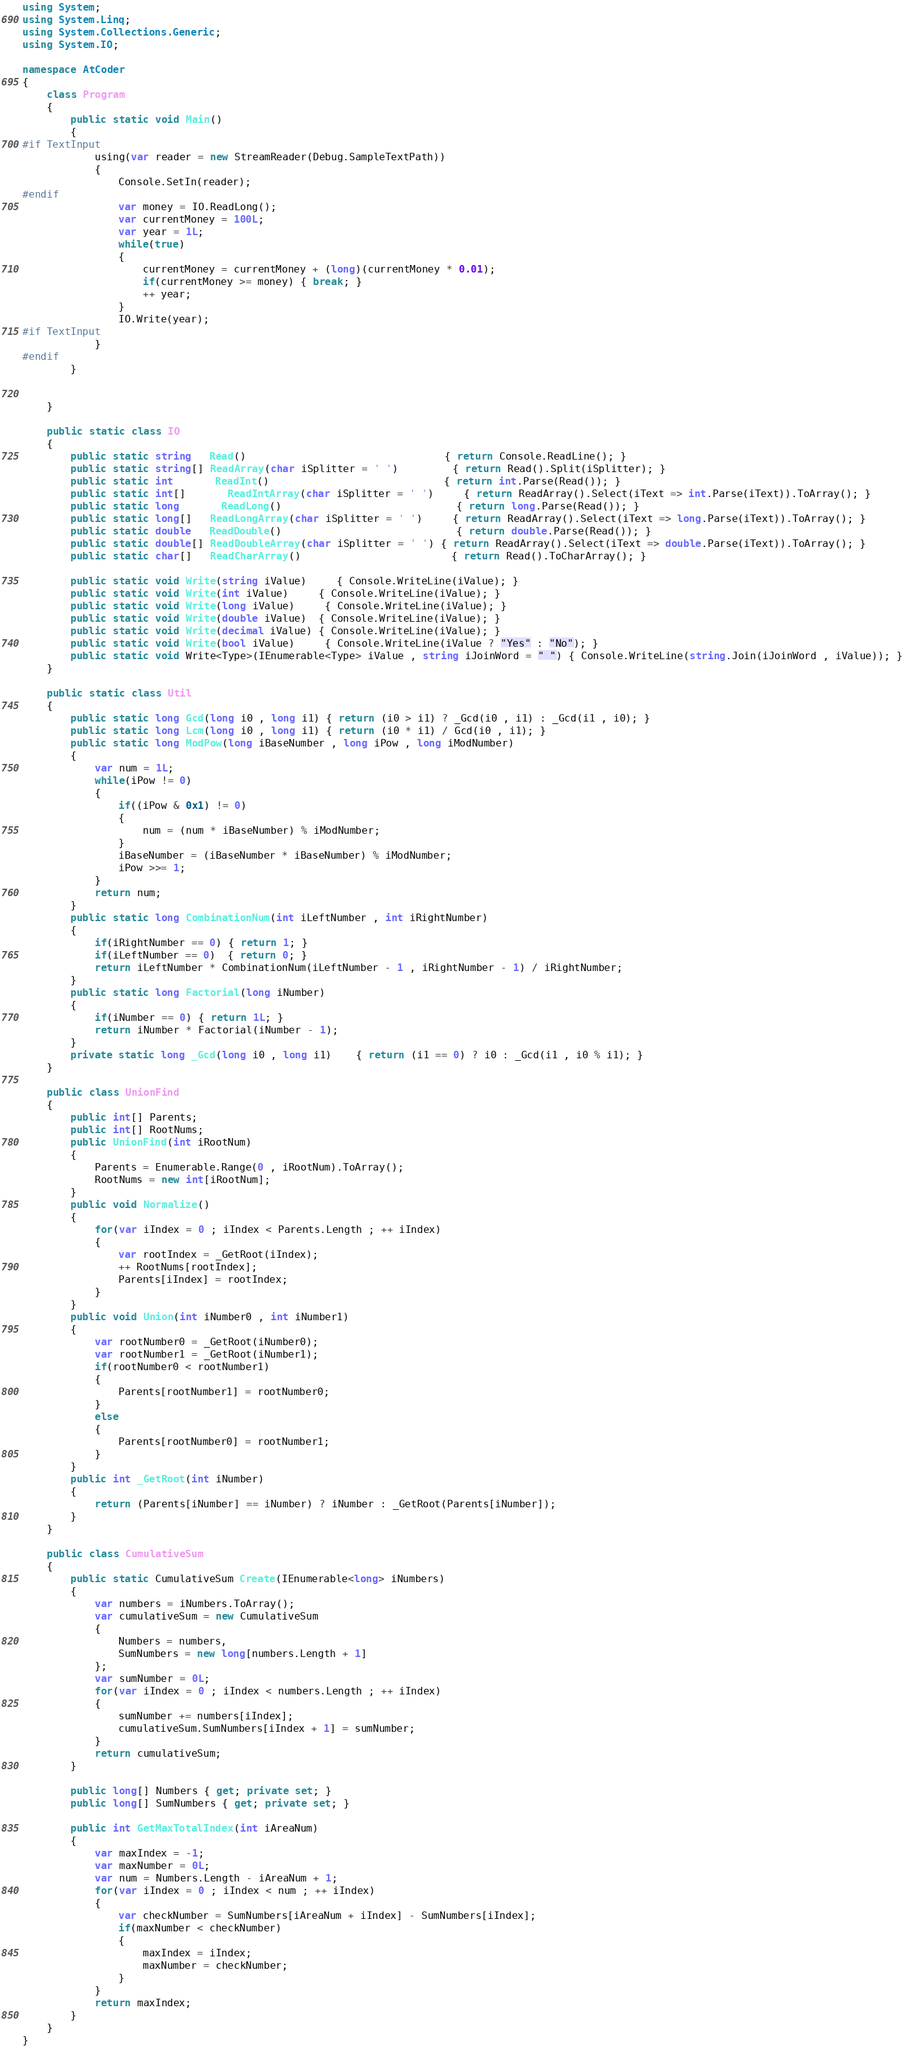Convert code to text. <code><loc_0><loc_0><loc_500><loc_500><_C#_>using System;
using System.Linq;
using System.Collections.Generic;
using System.IO;

namespace AtCoder
{
	class Program
	{
		public static void Main()
		{
#if TextInput
			using(var reader = new StreamReader(Debug.SampleTextPath)) 
			{
				Console.SetIn(reader);
#endif
				var money = IO.ReadLong();
				var currentMoney = 100L;
				var year = 1L;
				while(true)
				{
					currentMoney = currentMoney + (long)(currentMoney * 0.01);
					if(currentMoney >= money) { break; }
					++ year;
				}
				IO.Write(year);
#if TextInput
			}
#endif
		}

		
	}

	public static class IO
	{
		public static string   Read()								 { return Console.ReadLine(); }
		public static string[] ReadArray(char iSplitter = ' ')		 { return Read().Split(iSplitter); }
		public static int	   ReadInt()							 { return int.Parse(Read()); }
		public static int[]	   ReadIntArray(char iSplitter = ' ')	 { return ReadArray().Select(iText => int.Parse(iText)).ToArray(); }
		public static long	   ReadLong()							 { return long.Parse(Read()); }
		public static long[]   ReadLongArray(char iSplitter = ' ')	 { return ReadArray().Select(iText => long.Parse(iText)).ToArray(); }
		public static double   ReadDouble()							 { return double.Parse(Read()); }
		public static double[] ReadDoubleArray(char iSplitter = ' ') { return ReadArray().Select(iText => double.Parse(iText)).ToArray(); }
		public static char[]   ReadCharArray()						 { return Read().ToCharArray(); }

		public static void Write(string iValue)	 { Console.WriteLine(iValue); }
		public static void Write(int iValue)	 { Console.WriteLine(iValue); }
		public static void Write(long iValue)	 { Console.WriteLine(iValue); }
		public static void Write(double iValue)  { Console.WriteLine(iValue); }
		public static void Write(decimal iValue) { Console.WriteLine(iValue); }
		public static void Write(bool iValue)	 { Console.WriteLine(iValue ? "Yes" : "No"); }
		public static void Write<Type>(IEnumerable<Type> iValue , string iJoinWord = " ") { Console.WriteLine(string.Join(iJoinWord , iValue)); }
	}

	public static class Util
	{
		public static long Gcd(long i0 , long i1) { return (i0 > i1) ? _Gcd(i0 , i1) : _Gcd(i1 , i0); }
		public static long Lcm(long i0 , long i1) { return (i0 * i1) / Gcd(i0 , i1); }
		public static long ModPow(long iBaseNumber , long iPow , long iModNumber)
		{
			var num = 1L;
			while(iPow != 0)
			{
				if((iPow & 0x1) != 0)
				{
					num = (num * iBaseNumber) % iModNumber;
				}
				iBaseNumber = (iBaseNumber * iBaseNumber) % iModNumber;
				iPow >>= 1;
			}
			return num;
		}
		public static long CombinationNum(int iLeftNumber , int iRightNumber)
		{
			if(iRightNumber == 0) { return 1; }
			if(iLeftNumber == 0)  { return 0; }
			return iLeftNumber * CombinationNum(iLeftNumber - 1 , iRightNumber - 1) / iRightNumber;
		}
		public static long Factorial(long iNumber)
		{
			if(iNumber == 0) { return 1L; }
			return iNumber * Factorial(iNumber - 1);
		}
		private static long _Gcd(long i0 , long i1)	{ return (i1 == 0) ? i0 : _Gcd(i1 , i0 % i1); }
	}

	public class UnionFind
	{
		public int[] Parents;
		public int[] RootNums;
		public UnionFind(int iRootNum)
		{
			Parents = Enumerable.Range(0 , iRootNum).ToArray();
			RootNums = new int[iRootNum];
		}
		public void Normalize()
		{
			for(var iIndex = 0 ; iIndex < Parents.Length ; ++ iIndex)
			{
				var rootIndex = _GetRoot(iIndex);
				++ RootNums[rootIndex];
				Parents[iIndex] = rootIndex;
			}
		}
		public void Union(int iNumber0 , int iNumber1)
		{
			var rootNumber0 = _GetRoot(iNumber0);
			var rootNumber1 = _GetRoot(iNumber1);
			if(rootNumber0 < rootNumber1)
			{
				Parents[rootNumber1] = rootNumber0;
			}
			else
			{
				Parents[rootNumber0] = rootNumber1;
			}
		}
		public int _GetRoot(int iNumber)
		{
			return (Parents[iNumber] == iNumber) ? iNumber : _GetRoot(Parents[iNumber]);
		}
	}

	public class CumulativeSum
	{
		public static CumulativeSum Create(IEnumerable<long> iNumbers)
		{
			var numbers = iNumbers.ToArray();
			var cumulativeSum = new CumulativeSum
			{
				Numbers = numbers,
				SumNumbers = new long[numbers.Length + 1]
			};
			var sumNumber = 0L;
			for(var iIndex = 0 ; iIndex < numbers.Length ; ++ iIndex)
			{
				sumNumber += numbers[iIndex];
				cumulativeSum.SumNumbers[iIndex + 1] = sumNumber;
			}
			return cumulativeSum;
		}

		public long[] Numbers { get; private set; }
		public long[] SumNumbers { get; private set; }

		public int GetMaxTotalIndex(int iAreaNum)
		{
			var maxIndex = -1;
			var maxNumber = 0L;
			var num = Numbers.Length - iAreaNum + 1;
			for(var iIndex = 0 ; iIndex < num ; ++ iIndex)
			{
				var checkNumber = SumNumbers[iAreaNum + iIndex] - SumNumbers[iIndex];
				if(maxNumber < checkNumber) 
				{
					maxIndex = iIndex;
					maxNumber = checkNumber;
				}
			}
			return maxIndex;
		}
	}
}
</code> 